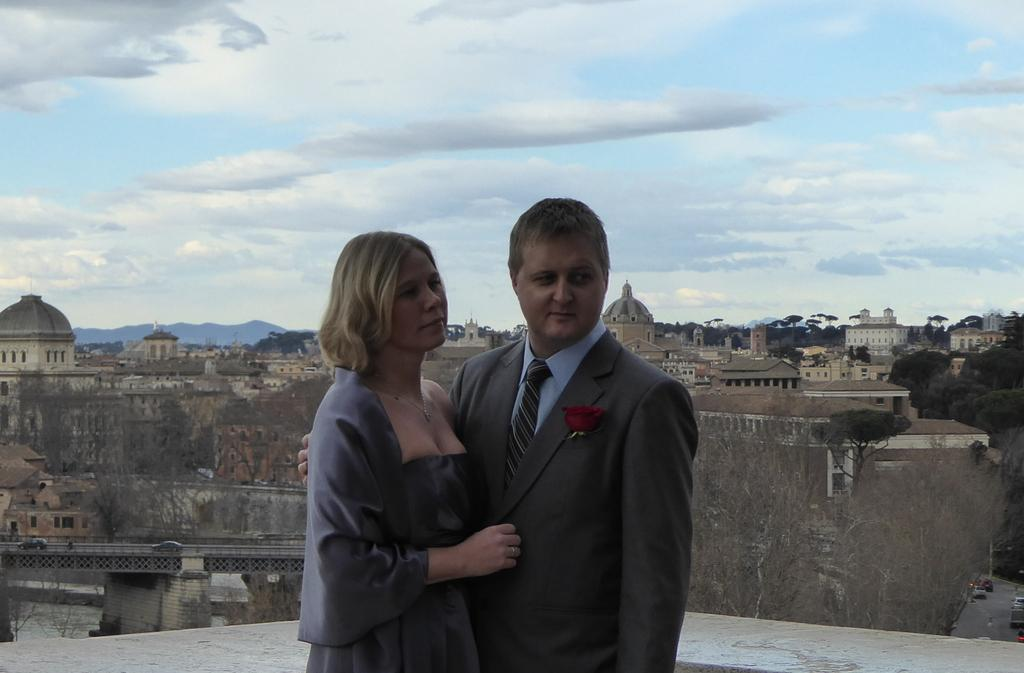How many people are in the image? There are two persons in the image. What type of structures can be seen in the image? There are buildings in the image. What architectural feature is present in the image? There is a bridge in the image. What type of vegetation is visible in the image? There are trees in the image. What type of natural landform is present in the image? There are hills in the image. What is visible in the sky in the image? The sky is visible in the image, and clouds are present. What theory is being tested in the image? There is no indication of a theory being tested in the image. What is being smashed in the image? There is no object being smashed in the image. 